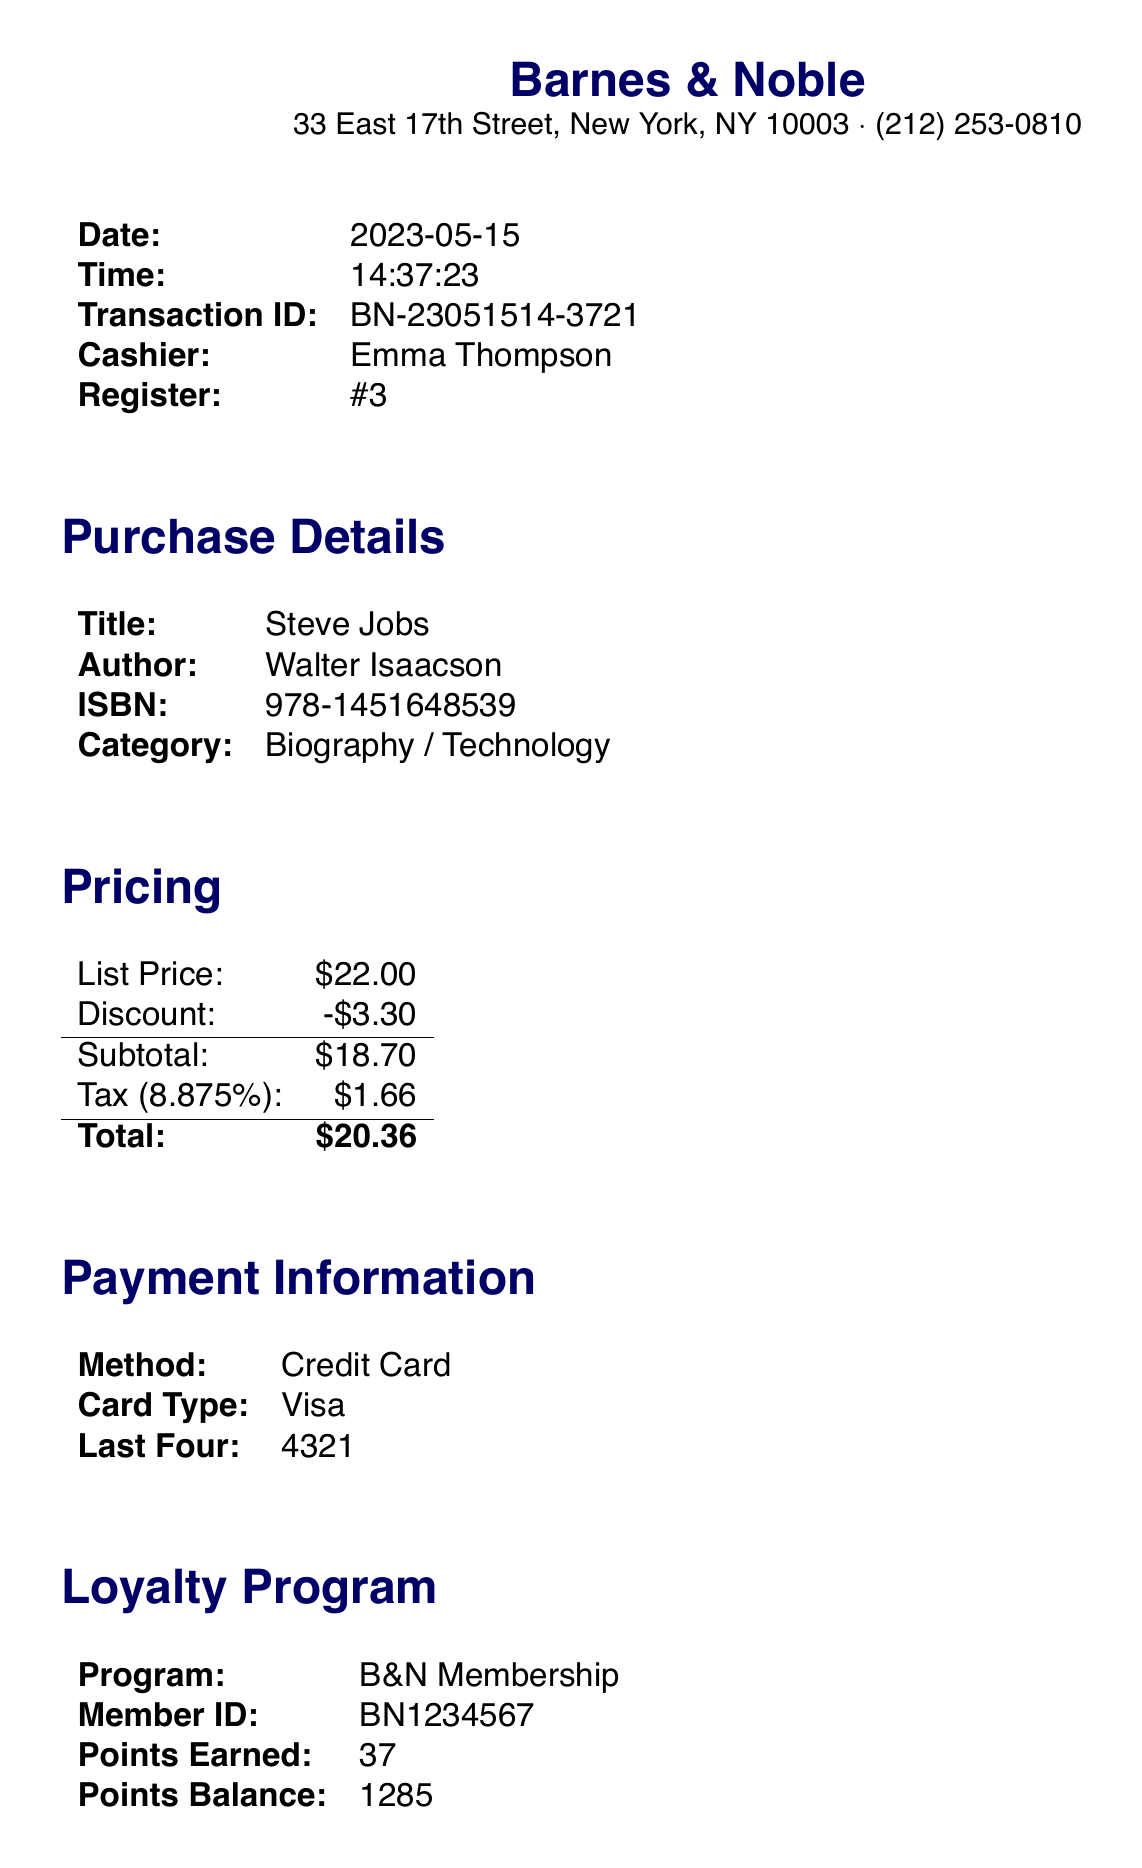What is the name of the store? The name of the store is provided in the document header.
Answer: Barnes & Noble What is the purchase date? The purchase date is clearly indicated in the purchase section of the document.
Answer: 2023-05-15 Who is the author of the book? The author’s name is mentioned under the purchase details.
Answer: Walter Isaacson How much tax was applied? The tax amount is calculated and presented in the pricing section.
Answer: $1.66 What is the total amount spent? The total amount is the final figure at the end of the pricing section.
Answer: $20.36 How many loyalty points were earned? The points earned are listed in the loyalty program section.
Answer: 37 What is the title of the book purchased? The title of the book is given in the purchase details section.
Answer: Steve Jobs What is the card type used for payment? The card type is specified in the payment information section.
Answer: Visa What is the transaction ID? The transaction ID is provided in the additional info section.
Answer: BN-23051514-3721 